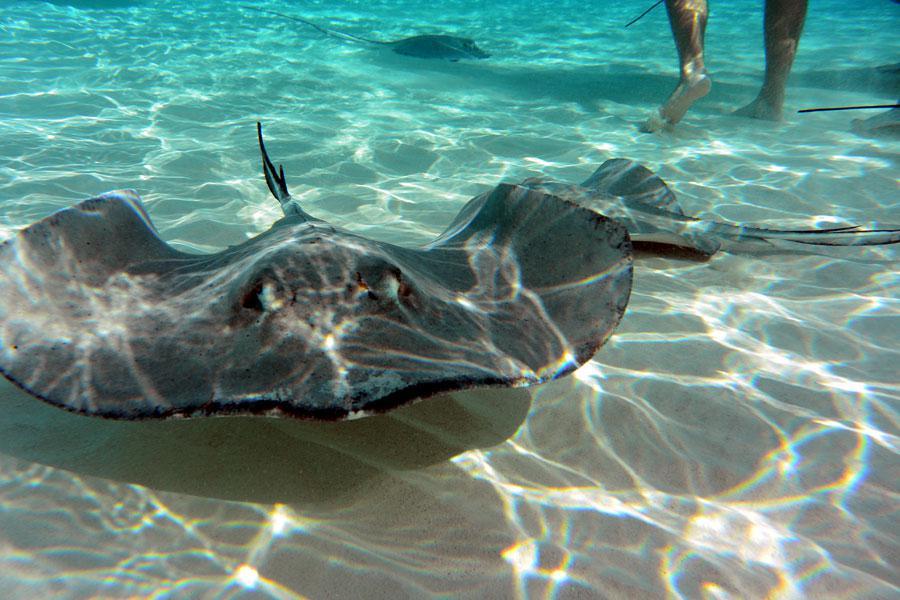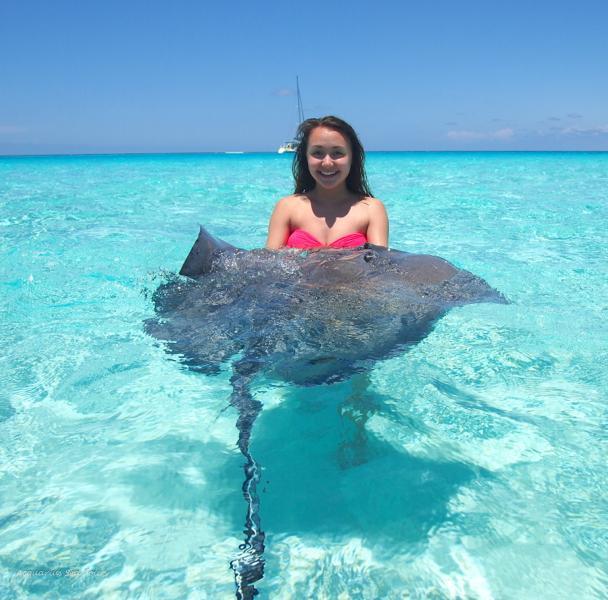The first image is the image on the left, the second image is the image on the right. Analyze the images presented: Is the assertion "The left image includes multiple people in the foreground, including a person with a stingray over part of their face." valid? Answer yes or no. No. The first image is the image on the left, the second image is the image on the right. Examine the images to the left and right. Is the description "In at least one image there is a man holding a stingray to the left of a little girl with goggles." accurate? Answer yes or no. No. 